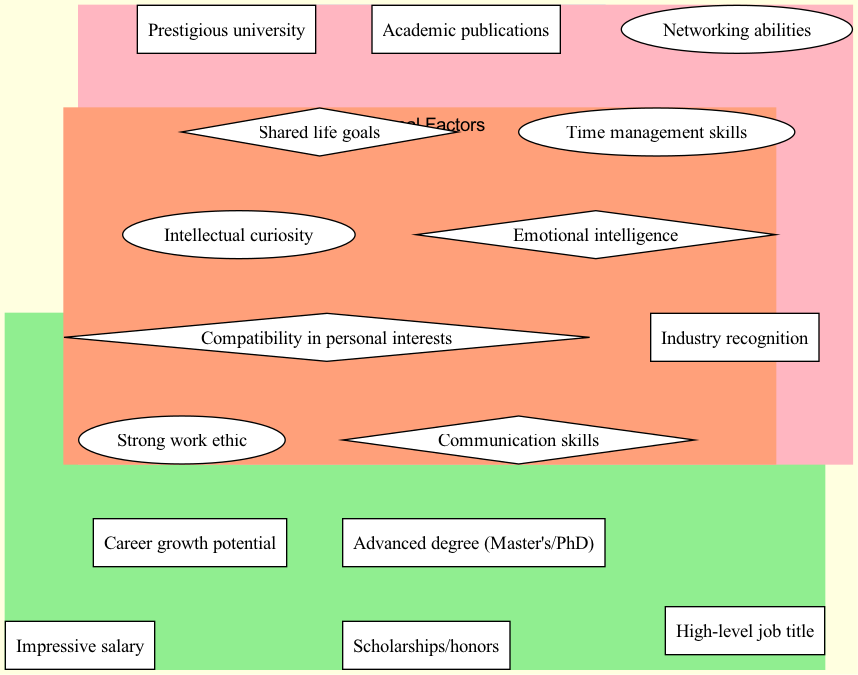What are two elements in the 'Academic Achievements' set? The 'Academic Achievements' set contains the elements 'Advanced degree (Master's/PhD)' and 'Prestigious university' among others. Therefore, selecting any two of these elements will answer the question.
Answer: Advanced degree (Master's/PhD), Prestigious university How many elements are in the 'Professional Success' set? The 'Professional Success' set contains four elements: 'High-level job title', 'Impressive salary', 'Career growth potential', and 'Industry recognition'. Counting these gives us the total number of elements.
Answer: 4 What is one common attribute shared between both sets? The intersection of the two sets includes the common attributes such as 'Strong work ethic', which indicates that this attribute is found in both the 'Academic Achievements' and 'Professional Success' sets.
Answer: Strong work ethic List one element from the 'External Factors' set. The 'External Factors' set includes elements such as 'Compatibility in personal interests', which shows that personal interests are considered important outside of academic and professional metrics.
Answer: Compatibility in personal interests What attribute suggests a factor of compatibility aside from academic and professional success? The 'External Factors' set contains various elements including 'Communication skills', which indicates that these skills suggest compatibility factors beyond academic and professional achievements.
Answer: Communication skills What attribute is found exclusively in the 'Professional Success' set? The elements in the 'Professional Success' set such as 'Impressive salary' are not present in the 'Academic Achievements' set, thus indicating their exclusive presence.
Answer: Impressive salary Which common attribute relates to personal effectiveness in both academic and professional contexts? The common attribute 'Time management skills' appears in the intersection of both sets, showing its relevance to both academic and professional effectiveness.
Answer: Time management skills What are the two sets of the Venn diagram? The diagram consists of two primary sets: 'Academic Achievements' and 'Professional Success', which categorize the key attributes of ideal partners.
Answer: Academic Achievements, Professional Success 